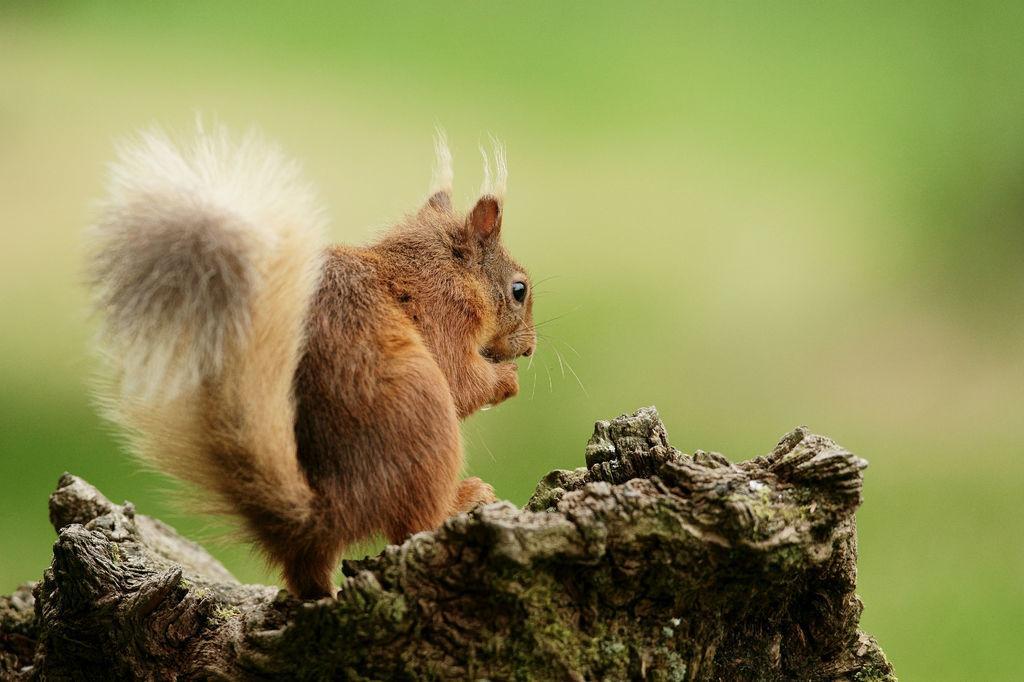Describe this image in one or two sentences. In the image in the center, we can see one wood. On the wood, we can see one squirrel, which is in brown and white color. 